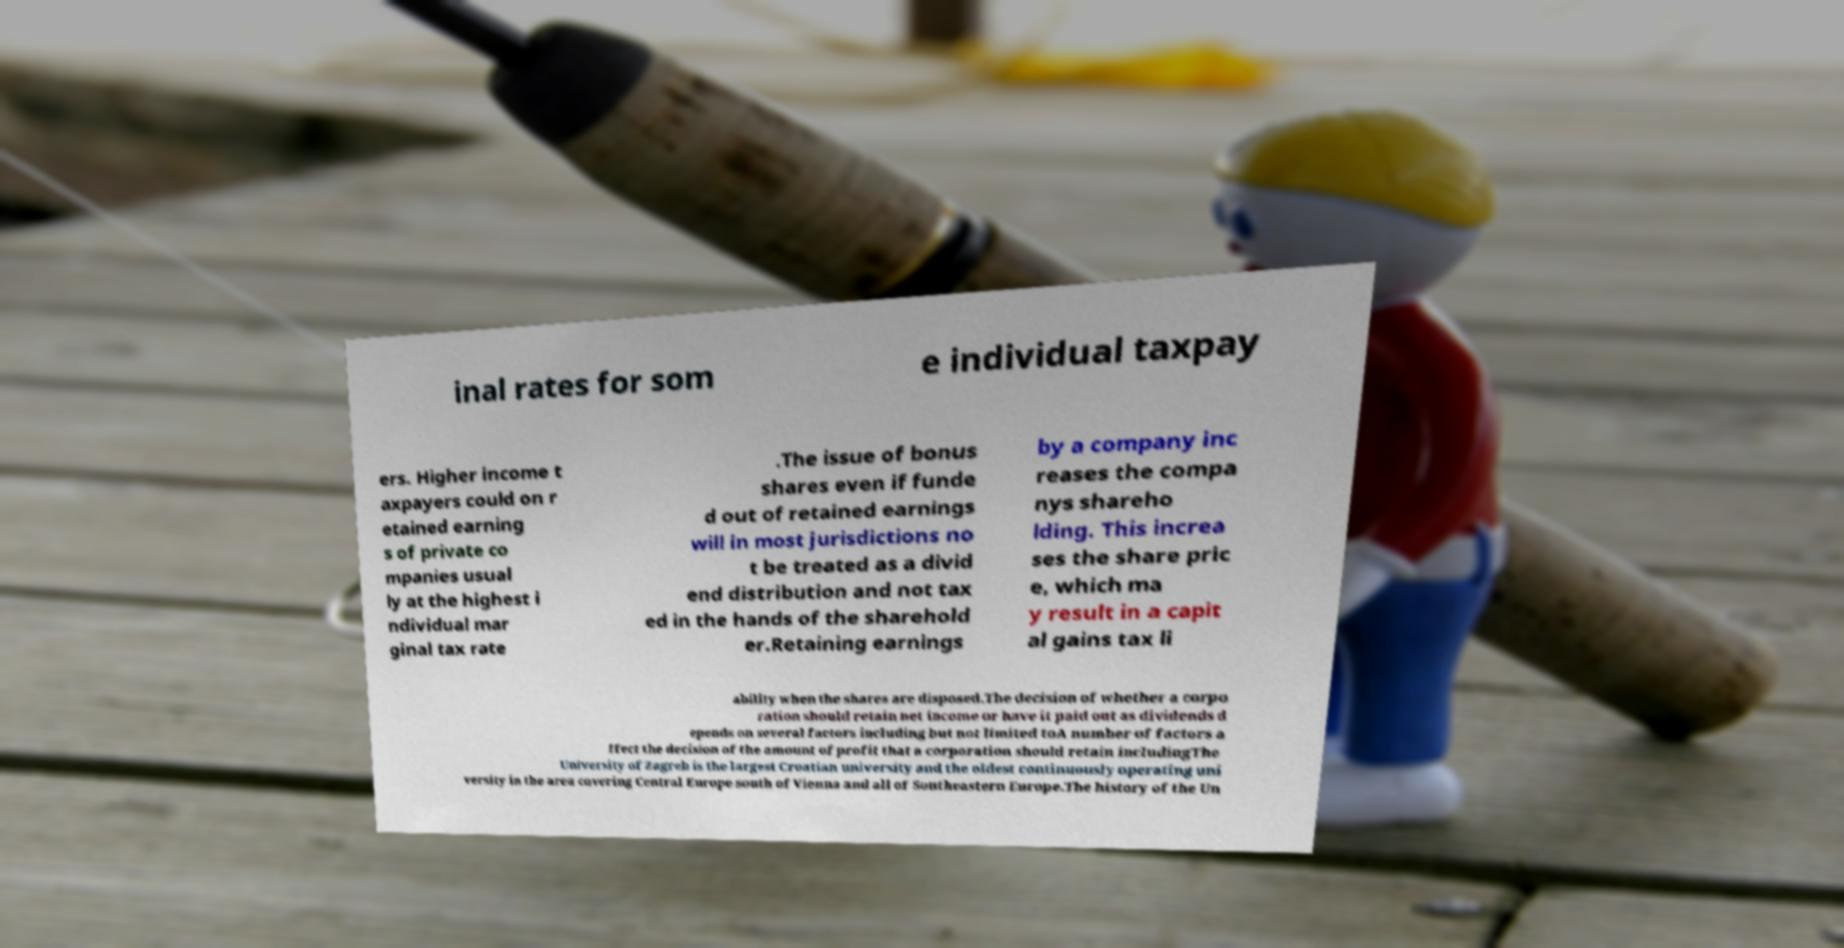For documentation purposes, I need the text within this image transcribed. Could you provide that? inal rates for som e individual taxpay ers. Higher income t axpayers could on r etained earning s of private co mpanies usual ly at the highest i ndividual mar ginal tax rate .The issue of bonus shares even if funde d out of retained earnings will in most jurisdictions no t be treated as a divid end distribution and not tax ed in the hands of the sharehold er.Retaining earnings by a company inc reases the compa nys shareho lding. This increa ses the share pric e, which ma y result in a capit al gains tax li ability when the shares are disposed.The decision of whether a corpo ration should retain net income or have it paid out as dividends d epends on several factors including but not limited toA number of factors a ffect the decision of the amount of profit that a corporation should retain includingThe University of Zagreb is the largest Croatian university and the oldest continuously operating uni versity in the area covering Central Europe south of Vienna and all of Southeastern Europe.The history of the Un 